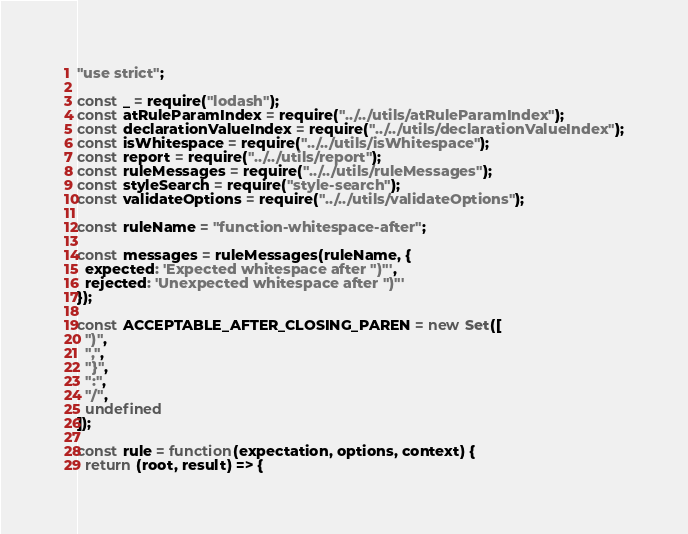<code> <loc_0><loc_0><loc_500><loc_500><_JavaScript_>"use strict";

const _ = require("lodash");
const atRuleParamIndex = require("../../utils/atRuleParamIndex");
const declarationValueIndex = require("../../utils/declarationValueIndex");
const isWhitespace = require("../../utils/isWhitespace");
const report = require("../../utils/report");
const ruleMessages = require("../../utils/ruleMessages");
const styleSearch = require("style-search");
const validateOptions = require("../../utils/validateOptions");

const ruleName = "function-whitespace-after";

const messages = ruleMessages(ruleName, {
  expected: 'Expected whitespace after ")"',
  rejected: 'Unexpected whitespace after ")"'
});

const ACCEPTABLE_AFTER_CLOSING_PAREN = new Set([
  ")",
  ",",
  "}",
  ":",
  "/",
  undefined
]);

const rule = function(expectation, options, context) {
  return (root, result) => {</code> 